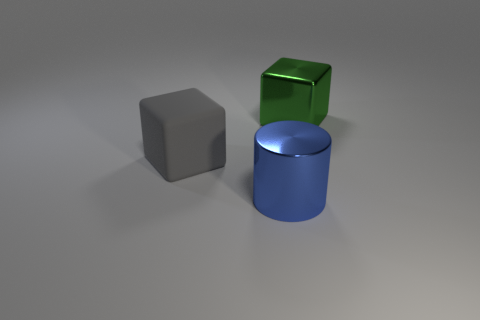Add 1 gray matte things. How many objects exist? 4 Subtract all cylinders. How many objects are left? 2 Add 3 big things. How many big things are left? 6 Add 2 gray objects. How many gray objects exist? 3 Subtract 0 yellow balls. How many objects are left? 3 Subtract all large gray cubes. Subtract all small green metal cylinders. How many objects are left? 2 